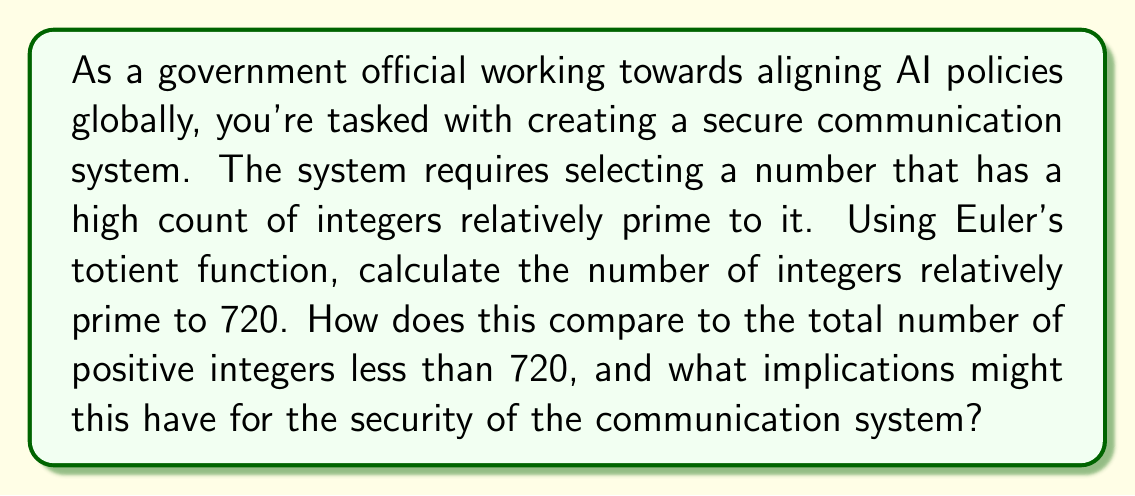Provide a solution to this math problem. To solve this problem, we'll use Euler's totient function, denoted as $\phi(n)$, which counts the number of integers up to $n$ that are relatively prime to $n$. For $n = 720$, we follow these steps:

1) First, factor 720 into its prime factors:
   $720 = 2^4 \times 3^2 \times 5$

2) The formula for Euler's totient function for a number $n$ with prime factorization $p_1^{a_1} \times p_2^{a_2} \times ... \times p_k^{a_k}$ is:

   $$\phi(n) = n \prod_{i=1}^k (1 - \frac{1}{p_i})$$

3) Applying this to our factorization:

   $$\phi(720) = 720 \times (1 - \frac{1}{2}) \times (1 - \frac{1}{3}) \times (1 - \frac{1}{5})$$

4) Simplify:
   $$\phi(720) = 720 \times \frac{1}{2} \times \frac{2}{3} \times \frac{4}{5} = 720 \times \frac{4}{15} = 192$$

5) To compare this to the total number of positive integers less than 720:
   $\frac{192}{719} \approx 0.267$ or about 26.7%

This means that approximately 26.7% of the numbers less than 720 are relatively prime to it. For a communication system, this provides a reasonably large pool of numbers to choose from for encryption keys, but it's not an exceptionally high ratio. Higher values (closer to 1) would generally indicate better security, as they provide more options for keys that are less likely to have common factors with the modulus.
Answer: There are 192 integers relatively prime to 720. This represents approximately 26.7% of the positive integers less than 720. 